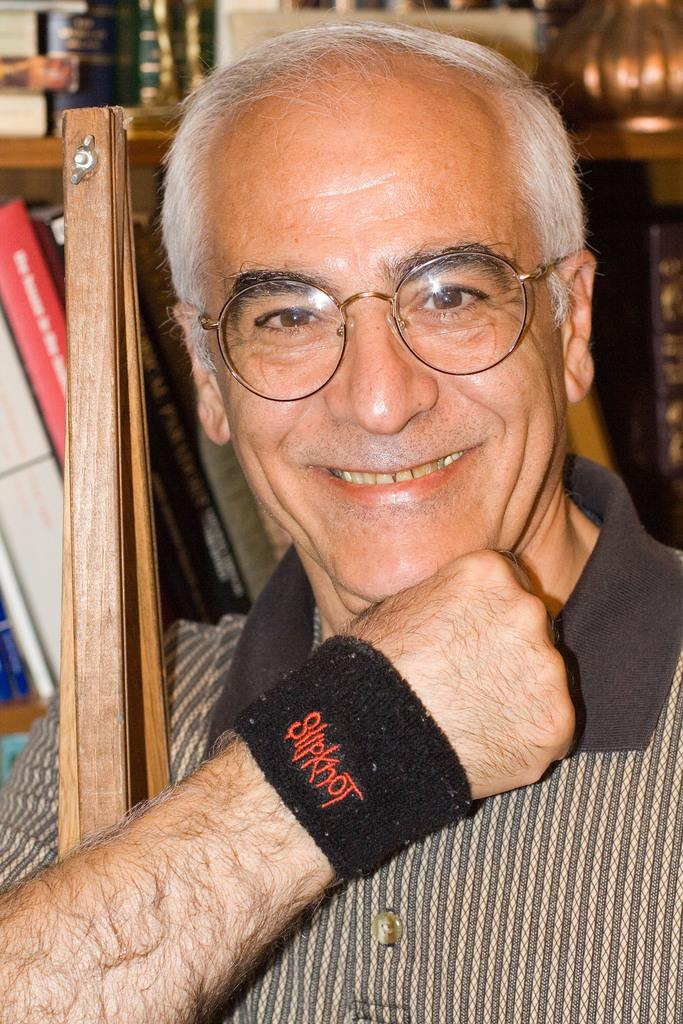What is the main subject of the picture? The main subject of the picture is a man. Can you describe the man's appearance? The man is wearing spectacles and a band. He is also smiling. What is the wooden object beside the man? There is a wooden object beside the man, but its specific nature cannot be determined from the provided facts. What can be seen at the back of the man? At the back of the man, there are books in racks and other objects visible. What type of appliance is the man using to write a letter in the image? There is no appliance visible in the image, nor is there any indication that the man is writing a letter. 